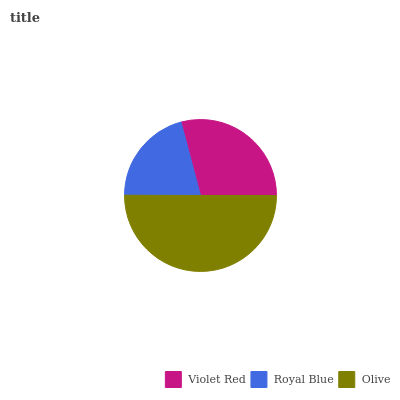Is Royal Blue the minimum?
Answer yes or no. Yes. Is Olive the maximum?
Answer yes or no. Yes. Is Olive the minimum?
Answer yes or no. No. Is Royal Blue the maximum?
Answer yes or no. No. Is Olive greater than Royal Blue?
Answer yes or no. Yes. Is Royal Blue less than Olive?
Answer yes or no. Yes. Is Royal Blue greater than Olive?
Answer yes or no. No. Is Olive less than Royal Blue?
Answer yes or no. No. Is Violet Red the high median?
Answer yes or no. Yes. Is Violet Red the low median?
Answer yes or no. Yes. Is Olive the high median?
Answer yes or no. No. Is Royal Blue the low median?
Answer yes or no. No. 